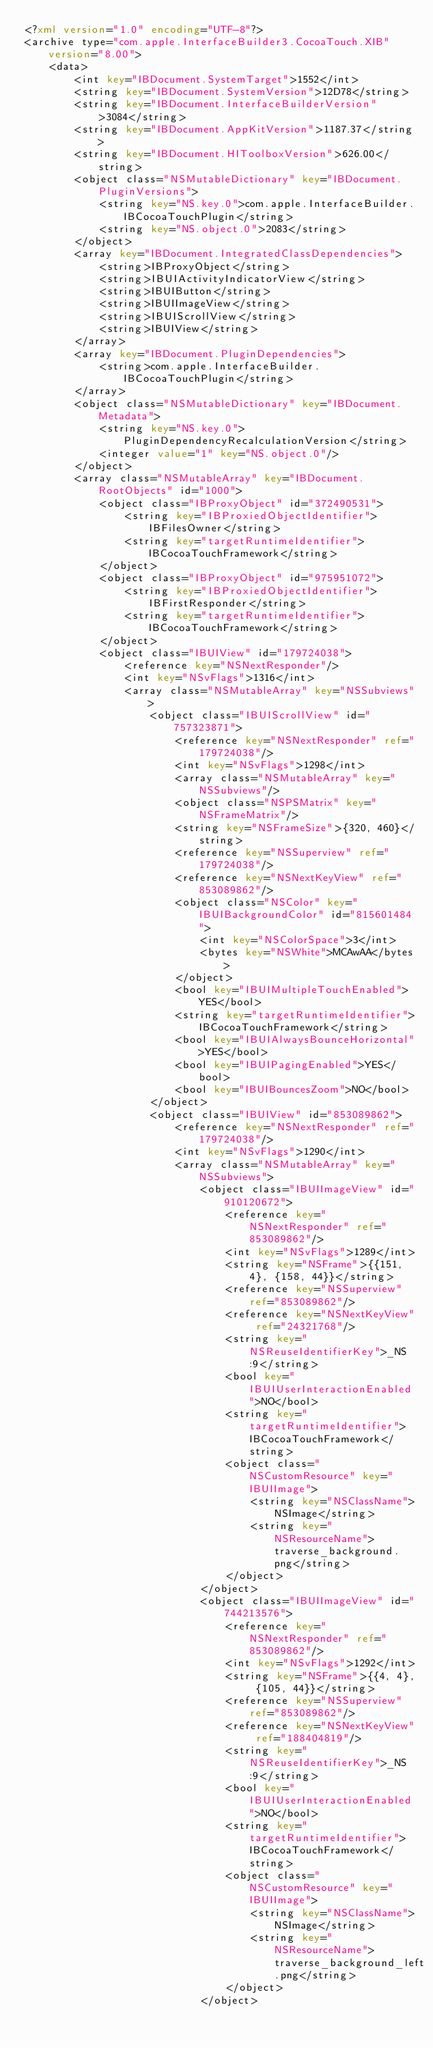<code> <loc_0><loc_0><loc_500><loc_500><_XML_><?xml version="1.0" encoding="UTF-8"?>
<archive type="com.apple.InterfaceBuilder3.CocoaTouch.XIB" version="8.00">
	<data>
		<int key="IBDocument.SystemTarget">1552</int>
		<string key="IBDocument.SystemVersion">12D78</string>
		<string key="IBDocument.InterfaceBuilderVersion">3084</string>
		<string key="IBDocument.AppKitVersion">1187.37</string>
		<string key="IBDocument.HIToolboxVersion">626.00</string>
		<object class="NSMutableDictionary" key="IBDocument.PluginVersions">
			<string key="NS.key.0">com.apple.InterfaceBuilder.IBCocoaTouchPlugin</string>
			<string key="NS.object.0">2083</string>
		</object>
		<array key="IBDocument.IntegratedClassDependencies">
			<string>IBProxyObject</string>
			<string>IBUIActivityIndicatorView</string>
			<string>IBUIButton</string>
			<string>IBUIImageView</string>
			<string>IBUIScrollView</string>
			<string>IBUIView</string>
		</array>
		<array key="IBDocument.PluginDependencies">
			<string>com.apple.InterfaceBuilder.IBCocoaTouchPlugin</string>
		</array>
		<object class="NSMutableDictionary" key="IBDocument.Metadata">
			<string key="NS.key.0">PluginDependencyRecalculationVersion</string>
			<integer value="1" key="NS.object.0"/>
		</object>
		<array class="NSMutableArray" key="IBDocument.RootObjects" id="1000">
			<object class="IBProxyObject" id="372490531">
				<string key="IBProxiedObjectIdentifier">IBFilesOwner</string>
				<string key="targetRuntimeIdentifier">IBCocoaTouchFramework</string>
			</object>
			<object class="IBProxyObject" id="975951072">
				<string key="IBProxiedObjectIdentifier">IBFirstResponder</string>
				<string key="targetRuntimeIdentifier">IBCocoaTouchFramework</string>
			</object>
			<object class="IBUIView" id="179724038">
				<reference key="NSNextResponder"/>
				<int key="NSvFlags">1316</int>
				<array class="NSMutableArray" key="NSSubviews">
					<object class="IBUIScrollView" id="757323871">
						<reference key="NSNextResponder" ref="179724038"/>
						<int key="NSvFlags">1298</int>
						<array class="NSMutableArray" key="NSSubviews"/>
						<object class="NSPSMatrix" key="NSFrameMatrix"/>
						<string key="NSFrameSize">{320, 460}</string>
						<reference key="NSSuperview" ref="179724038"/>
						<reference key="NSNextKeyView" ref="853089862"/>
						<object class="NSColor" key="IBUIBackgroundColor" id="815601484">
							<int key="NSColorSpace">3</int>
							<bytes key="NSWhite">MCAwAA</bytes>
						</object>
						<bool key="IBUIMultipleTouchEnabled">YES</bool>
						<string key="targetRuntimeIdentifier">IBCocoaTouchFramework</string>
						<bool key="IBUIAlwaysBounceHorizontal">YES</bool>
						<bool key="IBUIPagingEnabled">YES</bool>
						<bool key="IBUIBouncesZoom">NO</bool>
					</object>
					<object class="IBUIView" id="853089862">
						<reference key="NSNextResponder" ref="179724038"/>
						<int key="NSvFlags">1290</int>
						<array class="NSMutableArray" key="NSSubviews">
							<object class="IBUIImageView" id="910120672">
								<reference key="NSNextResponder" ref="853089862"/>
								<int key="NSvFlags">1289</int>
								<string key="NSFrame">{{151, 4}, {158, 44}}</string>
								<reference key="NSSuperview" ref="853089862"/>
								<reference key="NSNextKeyView" ref="24321768"/>
								<string key="NSReuseIdentifierKey">_NS:9</string>
								<bool key="IBUIUserInteractionEnabled">NO</bool>
								<string key="targetRuntimeIdentifier">IBCocoaTouchFramework</string>
								<object class="NSCustomResource" key="IBUIImage">
									<string key="NSClassName">NSImage</string>
									<string key="NSResourceName">traverse_background.png</string>
								</object>
							</object>
							<object class="IBUIImageView" id="744213576">
								<reference key="NSNextResponder" ref="853089862"/>
								<int key="NSvFlags">1292</int>
								<string key="NSFrame">{{4, 4}, {105, 44}}</string>
								<reference key="NSSuperview" ref="853089862"/>
								<reference key="NSNextKeyView" ref="188404819"/>
								<string key="NSReuseIdentifierKey">_NS:9</string>
								<bool key="IBUIUserInteractionEnabled">NO</bool>
								<string key="targetRuntimeIdentifier">IBCocoaTouchFramework</string>
								<object class="NSCustomResource" key="IBUIImage">
									<string key="NSClassName">NSImage</string>
									<string key="NSResourceName">traverse_background_left.png</string>
								</object>
							</object></code> 